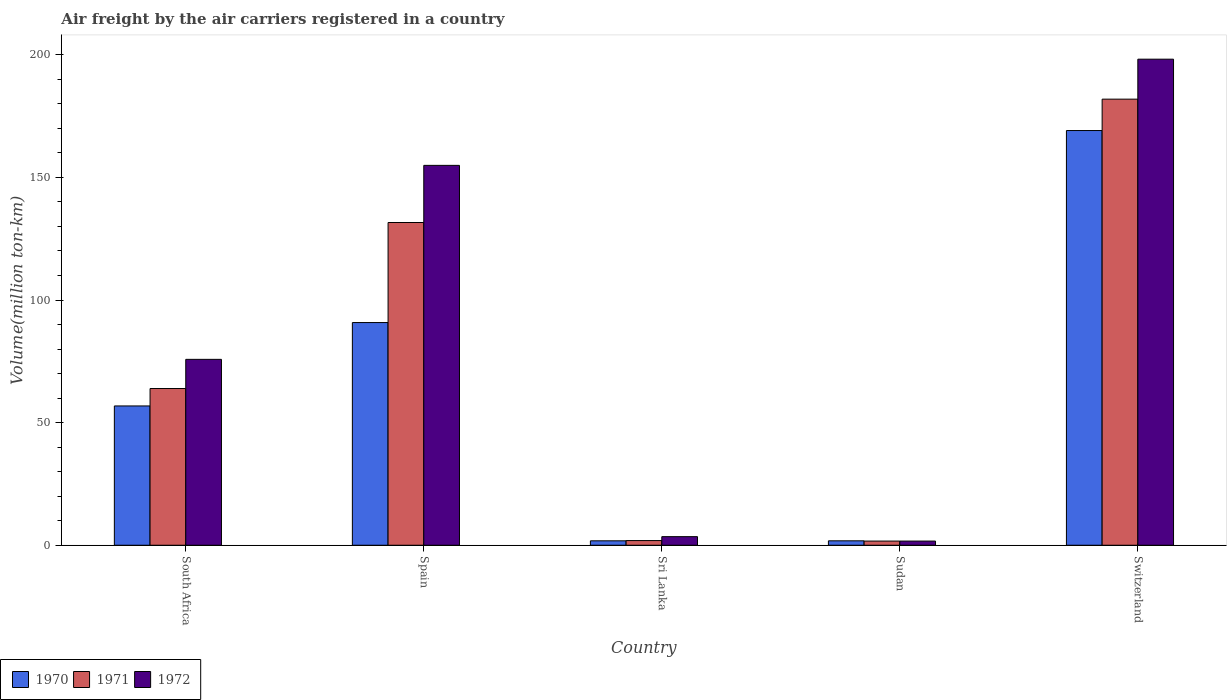How many groups of bars are there?
Provide a short and direct response. 5. Are the number of bars per tick equal to the number of legend labels?
Offer a very short reply. Yes. How many bars are there on the 1st tick from the left?
Ensure brevity in your answer.  3. How many bars are there on the 4th tick from the right?
Your answer should be compact. 3. What is the label of the 4th group of bars from the left?
Keep it short and to the point. Sudan. What is the volume of the air carriers in 1970 in Spain?
Provide a succinct answer. 90.8. Across all countries, what is the maximum volume of the air carriers in 1971?
Make the answer very short. 181.9. Across all countries, what is the minimum volume of the air carriers in 1972?
Provide a succinct answer. 1.7. In which country was the volume of the air carriers in 1970 maximum?
Your answer should be compact. Switzerland. In which country was the volume of the air carriers in 1970 minimum?
Offer a terse response. Sri Lanka. What is the total volume of the air carriers in 1970 in the graph?
Offer a terse response. 320.3. What is the difference between the volume of the air carriers in 1972 in South Africa and that in Switzerland?
Your answer should be very brief. -122.4. What is the difference between the volume of the air carriers in 1971 in Spain and the volume of the air carriers in 1972 in Sudan?
Your answer should be compact. 129.9. What is the average volume of the air carriers in 1970 per country?
Keep it short and to the point. 64.06. What is the difference between the volume of the air carriers of/in 1971 and volume of the air carriers of/in 1970 in Sudan?
Make the answer very short. -0.1. What is the ratio of the volume of the air carriers in 1971 in Spain to that in Sri Lanka?
Your answer should be compact. 69.26. Is the volume of the air carriers in 1972 in Sri Lanka less than that in Sudan?
Keep it short and to the point. No. Is the difference between the volume of the air carriers in 1971 in South Africa and Sri Lanka greater than the difference between the volume of the air carriers in 1970 in South Africa and Sri Lanka?
Your response must be concise. Yes. What is the difference between the highest and the second highest volume of the air carriers in 1970?
Your response must be concise. -112.3. What is the difference between the highest and the lowest volume of the air carriers in 1972?
Give a very brief answer. 196.5. What does the 1st bar from the left in South Africa represents?
Offer a very short reply. 1970. What does the 2nd bar from the right in Sri Lanka represents?
Your response must be concise. 1971. Are all the bars in the graph horizontal?
Your response must be concise. No. How many countries are there in the graph?
Offer a terse response. 5. Are the values on the major ticks of Y-axis written in scientific E-notation?
Offer a very short reply. No. Does the graph contain any zero values?
Make the answer very short. No. How are the legend labels stacked?
Your answer should be compact. Horizontal. What is the title of the graph?
Provide a succinct answer. Air freight by the air carriers registered in a country. What is the label or title of the X-axis?
Offer a terse response. Country. What is the label or title of the Y-axis?
Provide a short and direct response. Volume(million ton-km). What is the Volume(million ton-km) of 1970 in South Africa?
Keep it short and to the point. 56.8. What is the Volume(million ton-km) in 1971 in South Africa?
Your answer should be very brief. 63.9. What is the Volume(million ton-km) of 1972 in South Africa?
Keep it short and to the point. 75.8. What is the Volume(million ton-km) in 1970 in Spain?
Provide a short and direct response. 90.8. What is the Volume(million ton-km) in 1971 in Spain?
Your answer should be very brief. 131.6. What is the Volume(million ton-km) of 1972 in Spain?
Your response must be concise. 154.9. What is the Volume(million ton-km) in 1970 in Sri Lanka?
Give a very brief answer. 1.8. What is the Volume(million ton-km) in 1971 in Sri Lanka?
Provide a short and direct response. 1.9. What is the Volume(million ton-km) in 1972 in Sri Lanka?
Ensure brevity in your answer.  3.5. What is the Volume(million ton-km) of 1970 in Sudan?
Provide a succinct answer. 1.8. What is the Volume(million ton-km) of 1971 in Sudan?
Your answer should be very brief. 1.7. What is the Volume(million ton-km) of 1972 in Sudan?
Your answer should be compact. 1.7. What is the Volume(million ton-km) of 1970 in Switzerland?
Your response must be concise. 169.1. What is the Volume(million ton-km) in 1971 in Switzerland?
Keep it short and to the point. 181.9. What is the Volume(million ton-km) of 1972 in Switzerland?
Ensure brevity in your answer.  198.2. Across all countries, what is the maximum Volume(million ton-km) in 1970?
Your answer should be very brief. 169.1. Across all countries, what is the maximum Volume(million ton-km) in 1971?
Your answer should be very brief. 181.9. Across all countries, what is the maximum Volume(million ton-km) of 1972?
Keep it short and to the point. 198.2. Across all countries, what is the minimum Volume(million ton-km) in 1970?
Your answer should be very brief. 1.8. Across all countries, what is the minimum Volume(million ton-km) in 1971?
Give a very brief answer. 1.7. Across all countries, what is the minimum Volume(million ton-km) of 1972?
Offer a terse response. 1.7. What is the total Volume(million ton-km) in 1970 in the graph?
Your response must be concise. 320.3. What is the total Volume(million ton-km) in 1971 in the graph?
Provide a succinct answer. 381. What is the total Volume(million ton-km) of 1972 in the graph?
Ensure brevity in your answer.  434.1. What is the difference between the Volume(million ton-km) in 1970 in South Africa and that in Spain?
Keep it short and to the point. -34. What is the difference between the Volume(million ton-km) in 1971 in South Africa and that in Spain?
Offer a very short reply. -67.7. What is the difference between the Volume(million ton-km) in 1972 in South Africa and that in Spain?
Give a very brief answer. -79.1. What is the difference between the Volume(million ton-km) in 1970 in South Africa and that in Sri Lanka?
Keep it short and to the point. 55. What is the difference between the Volume(million ton-km) in 1972 in South Africa and that in Sri Lanka?
Provide a succinct answer. 72.3. What is the difference between the Volume(million ton-km) of 1971 in South Africa and that in Sudan?
Offer a very short reply. 62.2. What is the difference between the Volume(million ton-km) of 1972 in South Africa and that in Sudan?
Your response must be concise. 74.1. What is the difference between the Volume(million ton-km) of 1970 in South Africa and that in Switzerland?
Provide a succinct answer. -112.3. What is the difference between the Volume(million ton-km) in 1971 in South Africa and that in Switzerland?
Provide a succinct answer. -118. What is the difference between the Volume(million ton-km) in 1972 in South Africa and that in Switzerland?
Provide a short and direct response. -122.4. What is the difference between the Volume(million ton-km) in 1970 in Spain and that in Sri Lanka?
Provide a succinct answer. 89. What is the difference between the Volume(million ton-km) in 1971 in Spain and that in Sri Lanka?
Your answer should be compact. 129.7. What is the difference between the Volume(million ton-km) in 1972 in Spain and that in Sri Lanka?
Your answer should be very brief. 151.4. What is the difference between the Volume(million ton-km) in 1970 in Spain and that in Sudan?
Provide a short and direct response. 89. What is the difference between the Volume(million ton-km) in 1971 in Spain and that in Sudan?
Give a very brief answer. 129.9. What is the difference between the Volume(million ton-km) of 1972 in Spain and that in Sudan?
Give a very brief answer. 153.2. What is the difference between the Volume(million ton-km) of 1970 in Spain and that in Switzerland?
Make the answer very short. -78.3. What is the difference between the Volume(million ton-km) of 1971 in Spain and that in Switzerland?
Your response must be concise. -50.3. What is the difference between the Volume(million ton-km) of 1972 in Spain and that in Switzerland?
Your answer should be compact. -43.3. What is the difference between the Volume(million ton-km) of 1971 in Sri Lanka and that in Sudan?
Your answer should be very brief. 0.2. What is the difference between the Volume(million ton-km) in 1970 in Sri Lanka and that in Switzerland?
Provide a short and direct response. -167.3. What is the difference between the Volume(million ton-km) of 1971 in Sri Lanka and that in Switzerland?
Provide a short and direct response. -180. What is the difference between the Volume(million ton-km) in 1972 in Sri Lanka and that in Switzerland?
Your answer should be very brief. -194.7. What is the difference between the Volume(million ton-km) in 1970 in Sudan and that in Switzerland?
Offer a very short reply. -167.3. What is the difference between the Volume(million ton-km) of 1971 in Sudan and that in Switzerland?
Keep it short and to the point. -180.2. What is the difference between the Volume(million ton-km) in 1972 in Sudan and that in Switzerland?
Your response must be concise. -196.5. What is the difference between the Volume(million ton-km) of 1970 in South Africa and the Volume(million ton-km) of 1971 in Spain?
Give a very brief answer. -74.8. What is the difference between the Volume(million ton-km) in 1970 in South Africa and the Volume(million ton-km) in 1972 in Spain?
Offer a terse response. -98.1. What is the difference between the Volume(million ton-km) of 1971 in South Africa and the Volume(million ton-km) of 1972 in Spain?
Your response must be concise. -91. What is the difference between the Volume(million ton-km) of 1970 in South Africa and the Volume(million ton-km) of 1971 in Sri Lanka?
Offer a very short reply. 54.9. What is the difference between the Volume(million ton-km) of 1970 in South Africa and the Volume(million ton-km) of 1972 in Sri Lanka?
Provide a succinct answer. 53.3. What is the difference between the Volume(million ton-km) of 1971 in South Africa and the Volume(million ton-km) of 1972 in Sri Lanka?
Your response must be concise. 60.4. What is the difference between the Volume(million ton-km) of 1970 in South Africa and the Volume(million ton-km) of 1971 in Sudan?
Your answer should be very brief. 55.1. What is the difference between the Volume(million ton-km) in 1970 in South Africa and the Volume(million ton-km) in 1972 in Sudan?
Offer a terse response. 55.1. What is the difference between the Volume(million ton-km) of 1971 in South Africa and the Volume(million ton-km) of 1972 in Sudan?
Ensure brevity in your answer.  62.2. What is the difference between the Volume(million ton-km) of 1970 in South Africa and the Volume(million ton-km) of 1971 in Switzerland?
Offer a very short reply. -125.1. What is the difference between the Volume(million ton-km) of 1970 in South Africa and the Volume(million ton-km) of 1972 in Switzerland?
Your response must be concise. -141.4. What is the difference between the Volume(million ton-km) of 1971 in South Africa and the Volume(million ton-km) of 1972 in Switzerland?
Keep it short and to the point. -134.3. What is the difference between the Volume(million ton-km) of 1970 in Spain and the Volume(million ton-km) of 1971 in Sri Lanka?
Offer a very short reply. 88.9. What is the difference between the Volume(million ton-km) of 1970 in Spain and the Volume(million ton-km) of 1972 in Sri Lanka?
Ensure brevity in your answer.  87.3. What is the difference between the Volume(million ton-km) in 1971 in Spain and the Volume(million ton-km) in 1972 in Sri Lanka?
Your answer should be very brief. 128.1. What is the difference between the Volume(million ton-km) in 1970 in Spain and the Volume(million ton-km) in 1971 in Sudan?
Keep it short and to the point. 89.1. What is the difference between the Volume(million ton-km) of 1970 in Spain and the Volume(million ton-km) of 1972 in Sudan?
Your answer should be compact. 89.1. What is the difference between the Volume(million ton-km) in 1971 in Spain and the Volume(million ton-km) in 1972 in Sudan?
Offer a terse response. 129.9. What is the difference between the Volume(million ton-km) in 1970 in Spain and the Volume(million ton-km) in 1971 in Switzerland?
Your answer should be very brief. -91.1. What is the difference between the Volume(million ton-km) in 1970 in Spain and the Volume(million ton-km) in 1972 in Switzerland?
Make the answer very short. -107.4. What is the difference between the Volume(million ton-km) in 1971 in Spain and the Volume(million ton-km) in 1972 in Switzerland?
Your answer should be very brief. -66.6. What is the difference between the Volume(million ton-km) of 1970 in Sri Lanka and the Volume(million ton-km) of 1971 in Sudan?
Offer a very short reply. 0.1. What is the difference between the Volume(million ton-km) in 1971 in Sri Lanka and the Volume(million ton-km) in 1972 in Sudan?
Offer a terse response. 0.2. What is the difference between the Volume(million ton-km) in 1970 in Sri Lanka and the Volume(million ton-km) in 1971 in Switzerland?
Your answer should be very brief. -180.1. What is the difference between the Volume(million ton-km) of 1970 in Sri Lanka and the Volume(million ton-km) of 1972 in Switzerland?
Your answer should be compact. -196.4. What is the difference between the Volume(million ton-km) in 1971 in Sri Lanka and the Volume(million ton-km) in 1972 in Switzerland?
Ensure brevity in your answer.  -196.3. What is the difference between the Volume(million ton-km) in 1970 in Sudan and the Volume(million ton-km) in 1971 in Switzerland?
Your answer should be compact. -180.1. What is the difference between the Volume(million ton-km) in 1970 in Sudan and the Volume(million ton-km) in 1972 in Switzerland?
Provide a succinct answer. -196.4. What is the difference between the Volume(million ton-km) of 1971 in Sudan and the Volume(million ton-km) of 1972 in Switzerland?
Make the answer very short. -196.5. What is the average Volume(million ton-km) of 1970 per country?
Offer a very short reply. 64.06. What is the average Volume(million ton-km) of 1971 per country?
Offer a very short reply. 76.2. What is the average Volume(million ton-km) of 1972 per country?
Keep it short and to the point. 86.82. What is the difference between the Volume(million ton-km) of 1970 and Volume(million ton-km) of 1971 in South Africa?
Ensure brevity in your answer.  -7.1. What is the difference between the Volume(million ton-km) of 1970 and Volume(million ton-km) of 1972 in South Africa?
Your answer should be compact. -19. What is the difference between the Volume(million ton-km) of 1971 and Volume(million ton-km) of 1972 in South Africa?
Provide a short and direct response. -11.9. What is the difference between the Volume(million ton-km) of 1970 and Volume(million ton-km) of 1971 in Spain?
Offer a very short reply. -40.8. What is the difference between the Volume(million ton-km) in 1970 and Volume(million ton-km) in 1972 in Spain?
Provide a succinct answer. -64.1. What is the difference between the Volume(million ton-km) of 1971 and Volume(million ton-km) of 1972 in Spain?
Your answer should be very brief. -23.3. What is the difference between the Volume(million ton-km) in 1971 and Volume(million ton-km) in 1972 in Sri Lanka?
Your answer should be compact. -1.6. What is the difference between the Volume(million ton-km) in 1970 and Volume(million ton-km) in 1972 in Sudan?
Offer a terse response. 0.1. What is the difference between the Volume(million ton-km) in 1970 and Volume(million ton-km) in 1972 in Switzerland?
Provide a short and direct response. -29.1. What is the difference between the Volume(million ton-km) of 1971 and Volume(million ton-km) of 1972 in Switzerland?
Provide a succinct answer. -16.3. What is the ratio of the Volume(million ton-km) of 1970 in South Africa to that in Spain?
Your answer should be compact. 0.63. What is the ratio of the Volume(million ton-km) in 1971 in South Africa to that in Spain?
Your answer should be compact. 0.49. What is the ratio of the Volume(million ton-km) in 1972 in South Africa to that in Spain?
Your response must be concise. 0.49. What is the ratio of the Volume(million ton-km) in 1970 in South Africa to that in Sri Lanka?
Keep it short and to the point. 31.56. What is the ratio of the Volume(million ton-km) in 1971 in South Africa to that in Sri Lanka?
Ensure brevity in your answer.  33.63. What is the ratio of the Volume(million ton-km) in 1972 in South Africa to that in Sri Lanka?
Give a very brief answer. 21.66. What is the ratio of the Volume(million ton-km) in 1970 in South Africa to that in Sudan?
Keep it short and to the point. 31.56. What is the ratio of the Volume(million ton-km) in 1971 in South Africa to that in Sudan?
Ensure brevity in your answer.  37.59. What is the ratio of the Volume(million ton-km) of 1972 in South Africa to that in Sudan?
Give a very brief answer. 44.59. What is the ratio of the Volume(million ton-km) of 1970 in South Africa to that in Switzerland?
Make the answer very short. 0.34. What is the ratio of the Volume(million ton-km) in 1971 in South Africa to that in Switzerland?
Your response must be concise. 0.35. What is the ratio of the Volume(million ton-km) of 1972 in South Africa to that in Switzerland?
Offer a terse response. 0.38. What is the ratio of the Volume(million ton-km) in 1970 in Spain to that in Sri Lanka?
Your answer should be very brief. 50.44. What is the ratio of the Volume(million ton-km) in 1971 in Spain to that in Sri Lanka?
Give a very brief answer. 69.26. What is the ratio of the Volume(million ton-km) in 1972 in Spain to that in Sri Lanka?
Provide a succinct answer. 44.26. What is the ratio of the Volume(million ton-km) of 1970 in Spain to that in Sudan?
Give a very brief answer. 50.44. What is the ratio of the Volume(million ton-km) in 1971 in Spain to that in Sudan?
Your answer should be very brief. 77.41. What is the ratio of the Volume(million ton-km) in 1972 in Spain to that in Sudan?
Your answer should be compact. 91.12. What is the ratio of the Volume(million ton-km) in 1970 in Spain to that in Switzerland?
Your response must be concise. 0.54. What is the ratio of the Volume(million ton-km) of 1971 in Spain to that in Switzerland?
Provide a succinct answer. 0.72. What is the ratio of the Volume(million ton-km) of 1972 in Spain to that in Switzerland?
Give a very brief answer. 0.78. What is the ratio of the Volume(million ton-km) of 1970 in Sri Lanka to that in Sudan?
Ensure brevity in your answer.  1. What is the ratio of the Volume(million ton-km) in 1971 in Sri Lanka to that in Sudan?
Provide a succinct answer. 1.12. What is the ratio of the Volume(million ton-km) in 1972 in Sri Lanka to that in Sudan?
Give a very brief answer. 2.06. What is the ratio of the Volume(million ton-km) in 1970 in Sri Lanka to that in Switzerland?
Keep it short and to the point. 0.01. What is the ratio of the Volume(million ton-km) in 1971 in Sri Lanka to that in Switzerland?
Give a very brief answer. 0.01. What is the ratio of the Volume(million ton-km) of 1972 in Sri Lanka to that in Switzerland?
Make the answer very short. 0.02. What is the ratio of the Volume(million ton-km) of 1970 in Sudan to that in Switzerland?
Your answer should be compact. 0.01. What is the ratio of the Volume(million ton-km) in 1971 in Sudan to that in Switzerland?
Ensure brevity in your answer.  0.01. What is the ratio of the Volume(million ton-km) in 1972 in Sudan to that in Switzerland?
Your answer should be very brief. 0.01. What is the difference between the highest and the second highest Volume(million ton-km) in 1970?
Give a very brief answer. 78.3. What is the difference between the highest and the second highest Volume(million ton-km) of 1971?
Ensure brevity in your answer.  50.3. What is the difference between the highest and the second highest Volume(million ton-km) of 1972?
Your response must be concise. 43.3. What is the difference between the highest and the lowest Volume(million ton-km) of 1970?
Ensure brevity in your answer.  167.3. What is the difference between the highest and the lowest Volume(million ton-km) in 1971?
Your answer should be compact. 180.2. What is the difference between the highest and the lowest Volume(million ton-km) in 1972?
Provide a short and direct response. 196.5. 